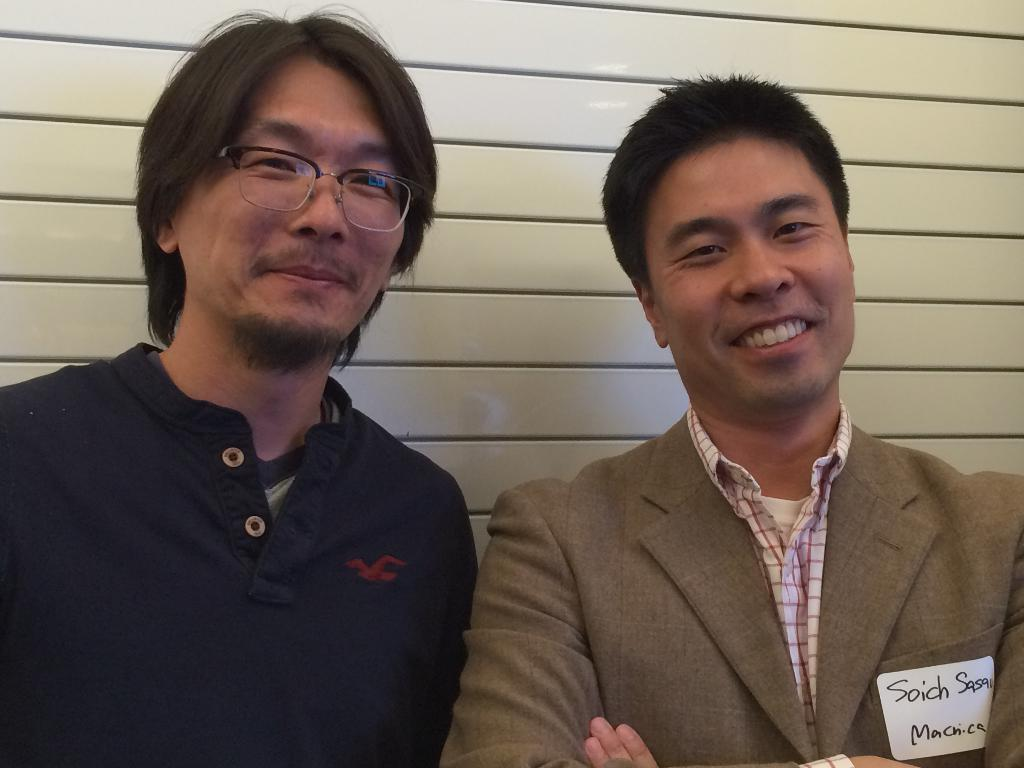How many people are in the image? There are two people standing in the image. What are the people doing in the image? The people are posing for a picture. What is one person wearing in the image? One person is wearing a suit. Can you describe any details about the suit? The suit has a label with some text on the pocket. What type of payment is being made in the image? There is no payment being made in the image; it features two people posing for a picture. Can you see any bubbles in the image? There are no bubbles present in the image. 